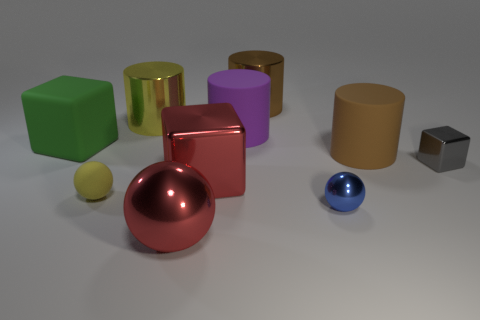Subtract all purple cylinders. How many cylinders are left? 3 Subtract all purple cylinders. How many cylinders are left? 3 Subtract all blocks. How many objects are left? 7 Subtract 1 cylinders. How many cylinders are left? 3 Subtract all green cylinders. How many green cubes are left? 1 Subtract all large gray metal cylinders. Subtract all purple objects. How many objects are left? 9 Add 9 small blue balls. How many small blue balls are left? 10 Add 1 big red spheres. How many big red spheres exist? 2 Subtract 0 yellow blocks. How many objects are left? 10 Subtract all cyan cylinders. Subtract all green cubes. How many cylinders are left? 4 